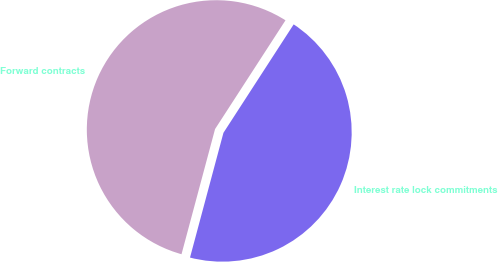Convert chart to OTSL. <chart><loc_0><loc_0><loc_500><loc_500><pie_chart><fcel>Interest rate lock commitments<fcel>Forward contracts<nl><fcel>45.02%<fcel>54.98%<nl></chart> 